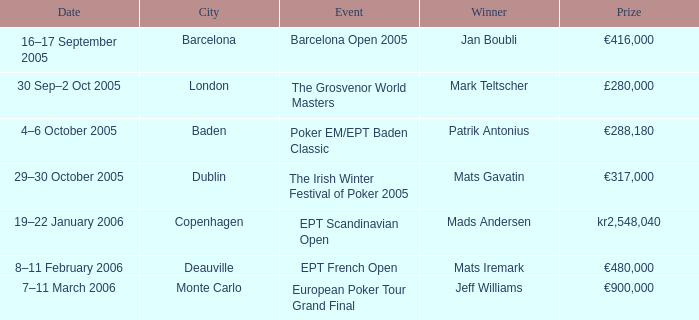What event had a prize of €900,000? European Poker Tour Grand Final. 